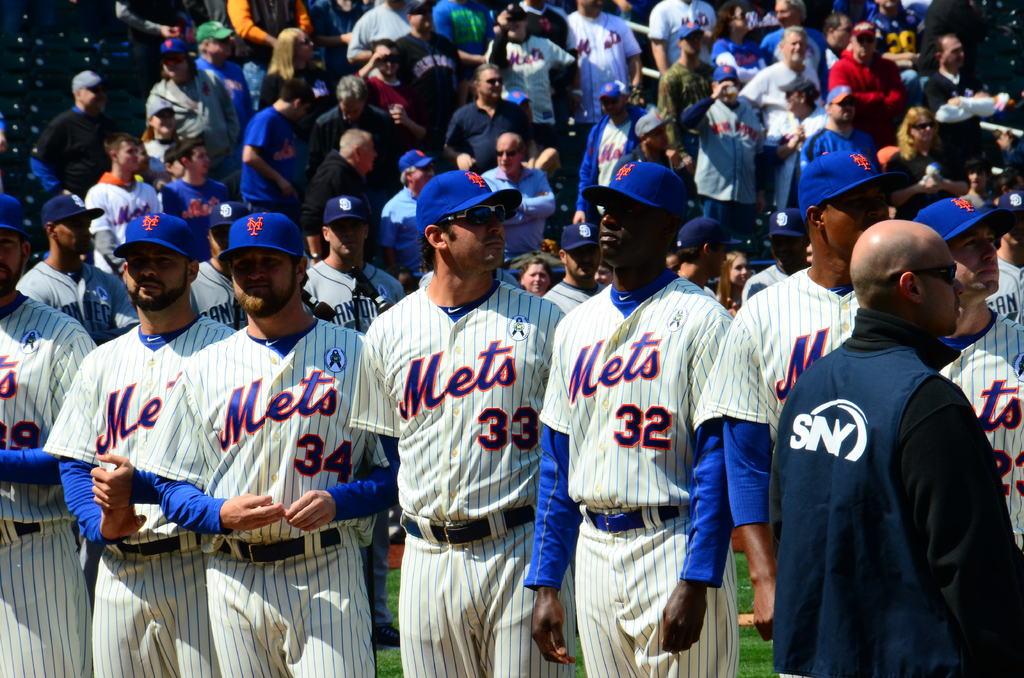What shirt number does the player to the right of shirt number 34 have?
Keep it short and to the point. 33. What player number is furthest to the right?
Your response must be concise. 32. 